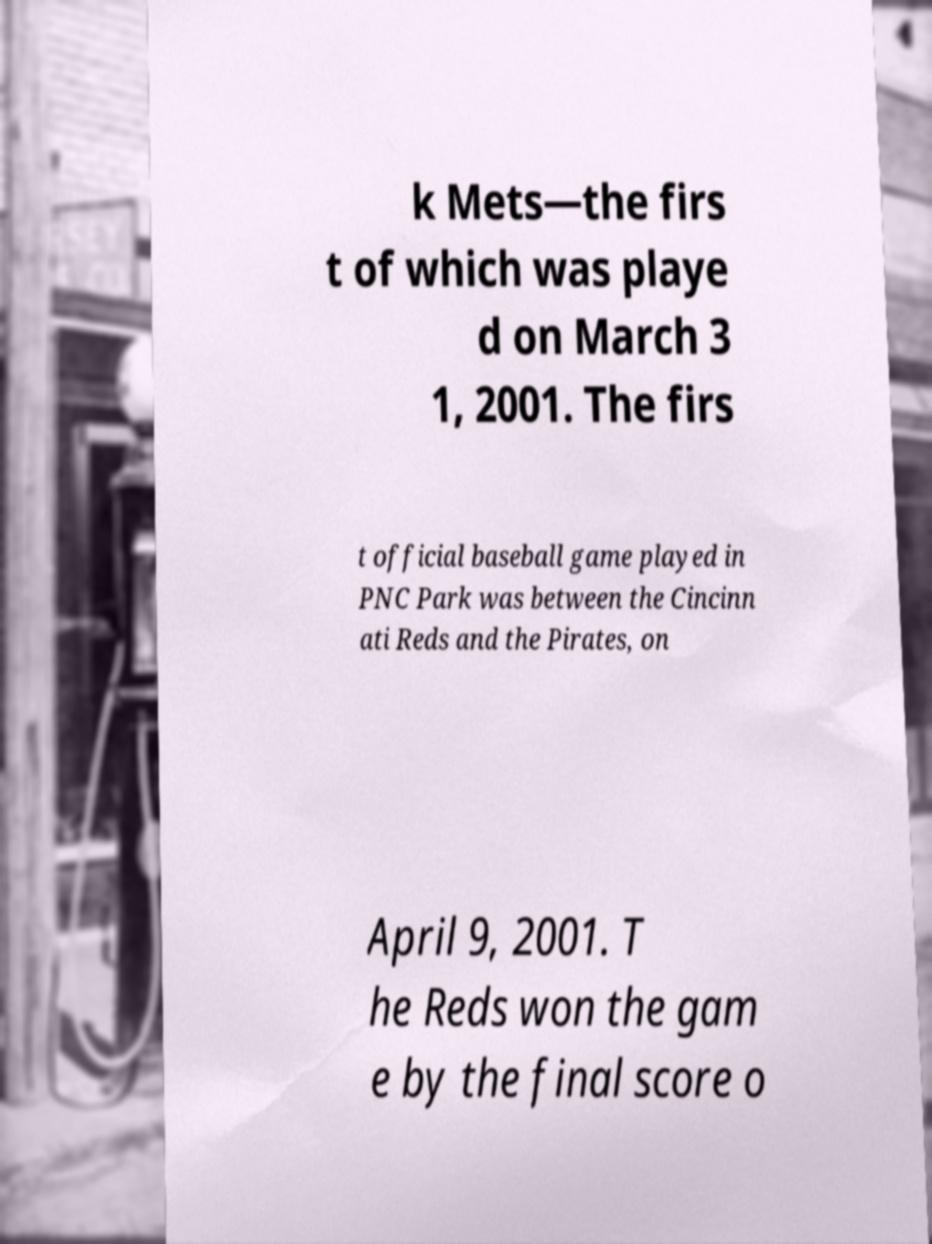There's text embedded in this image that I need extracted. Can you transcribe it verbatim? k Mets—the firs t of which was playe d on March 3 1, 2001. The firs t official baseball game played in PNC Park was between the Cincinn ati Reds and the Pirates, on April 9, 2001. T he Reds won the gam e by the final score o 